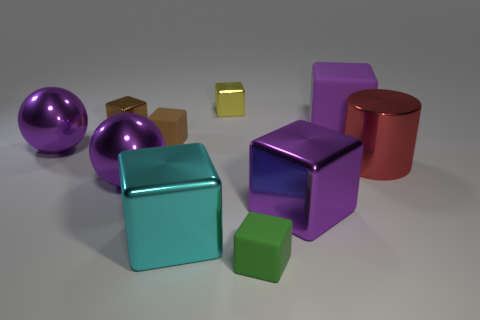What number of large things are red rubber cubes or cyan metal blocks?
Give a very brief answer. 1. What color is the large metallic cylinder?
Provide a short and direct response. Red. There is a cube that is behind the large purple matte cube; is there a brown matte cube that is to the right of it?
Offer a terse response. No. Is the number of green blocks that are behind the small brown rubber block less than the number of small purple cylinders?
Your answer should be compact. No. Is the material of the big purple ball that is to the left of the small brown metallic thing the same as the small green thing?
Your answer should be very brief. No. The big cube that is made of the same material as the small green cube is what color?
Your answer should be compact. Purple. Is the number of large blocks in front of the large red thing less than the number of tiny cubes in front of the small yellow metal object?
Your answer should be very brief. Yes. There is a big metallic cube that is behind the cyan thing; is its color the same as the rubber object on the right side of the green rubber block?
Provide a succinct answer. Yes. Is there a yellow block that has the same material as the green cube?
Your response must be concise. No. There is a purple shiny object behind the metallic thing on the right side of the purple matte cube; how big is it?
Make the answer very short. Large. 